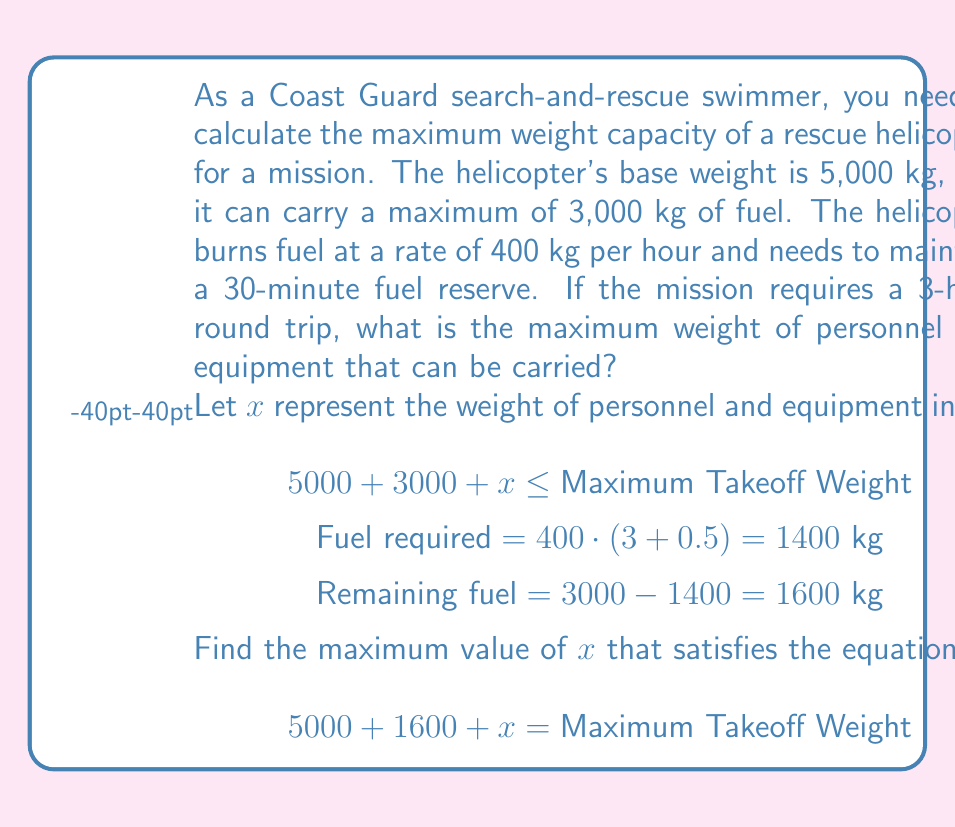Provide a solution to this math problem. To solve this problem, we need to follow these steps:

1) First, calculate the total fuel required for the mission:
   - Flight time: 3 hours
   - Reserve time: 0.5 hours
   - Total time: 3.5 hours
   - Fuel consumption: $400 \text{ kg/hour} \cdot 3.5 \text{ hours} = 1400 \text{ kg}$

2) Calculate the remaining fuel after the mission:
   - Total fuel capacity: 3000 kg
   - Fuel required: 1400 kg
   - Remaining fuel: $3000 - 1400 = 1600 \text{ kg}$

3) Set up the equation for the maximum takeoff weight:
   $$5000 + 1600 + x = \text{Maximum Takeoff Weight}$$
   Where:
   - 5000 kg is the base weight of the helicopter
   - 1600 kg is the remaining fuel
   - $x$ is the weight of personnel and equipment

4) The maximum takeoff weight is the sum of the base weight, total fuel capacity, and maximum personnel/equipment weight:
   $$\text{Maximum Takeoff Weight} = 5000 + 3000 + \text{Maximum }x$$

5) Substitute this into our equation:
   $$5000 + 1600 + x = 5000 + 3000 + \text{Maximum }x$$

6) Simplify:
   $$6600 + x = 8000 + \text{Maximum }x$$

7) Solve for x:
   $$x = 1400$$

Therefore, the maximum weight of personnel and equipment that can be carried is 1400 kg.
Answer: The maximum weight of personnel and equipment that can be carried is 1400 kg. 